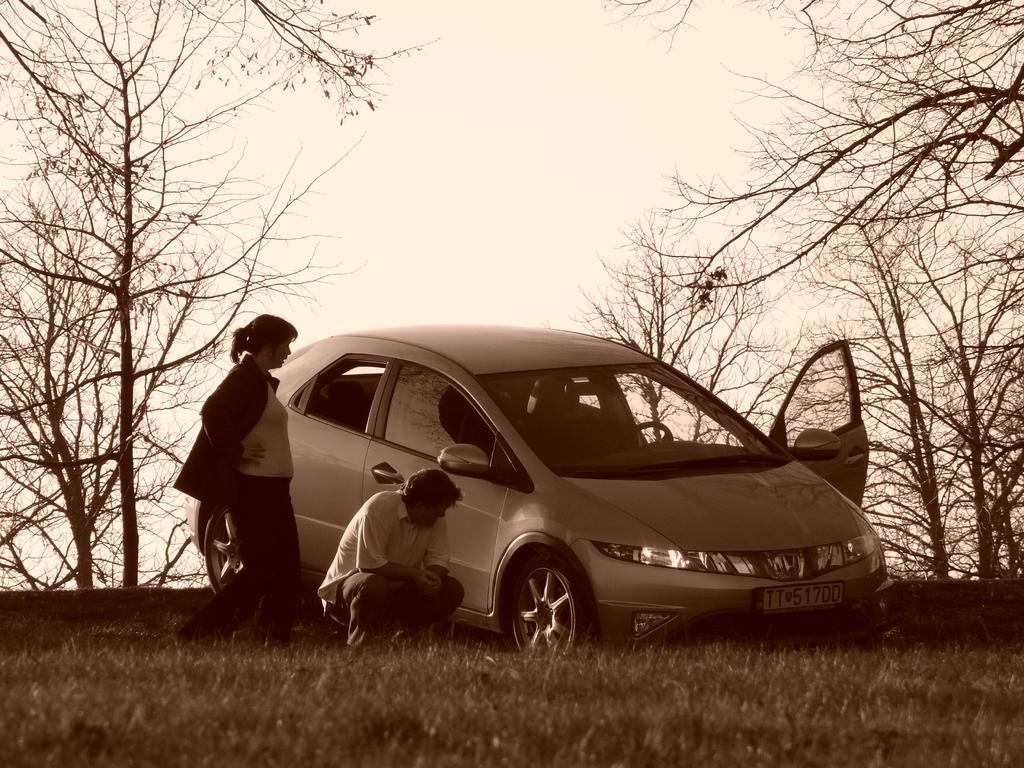Could you give a brief overview of what you see in this image? In the middle of this image, there is a vehicle having one door opens on the ground. Besides this vehicle, there are two persons. One of them is squatting and watching something on the vehicle. These both persons on the ground, on which there is grass. In the background, there are trees and there are clouds in the sky. 